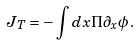<formula> <loc_0><loc_0><loc_500><loc_500>J _ { T } = - \int d x \Pi \partial _ { x } \phi \, .</formula> 